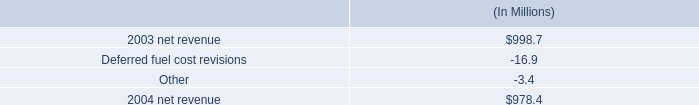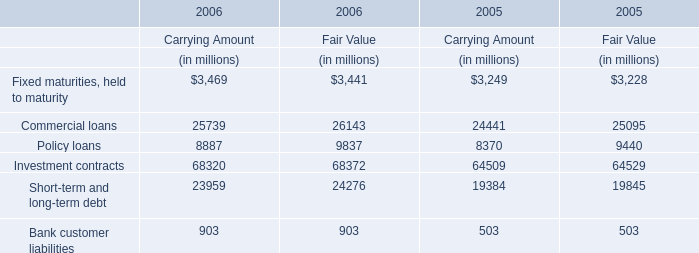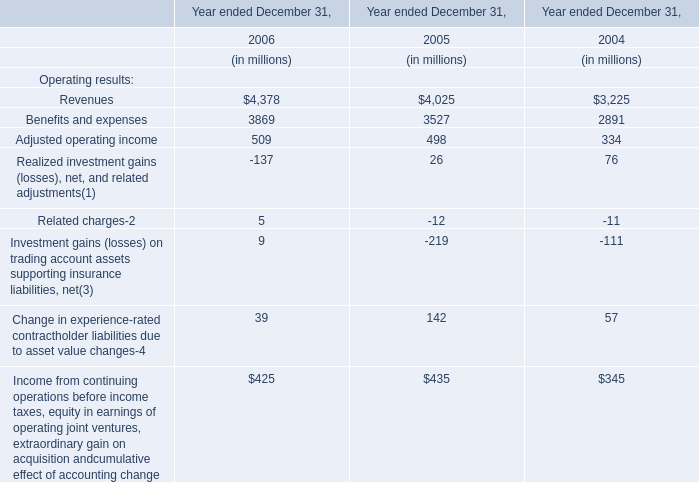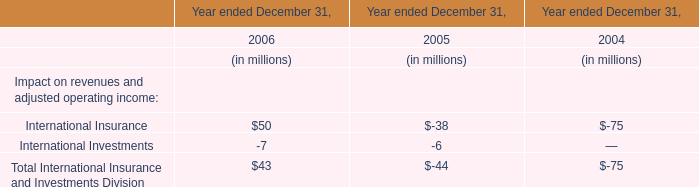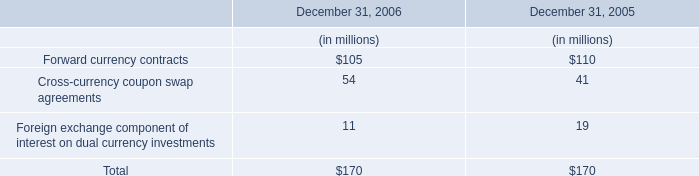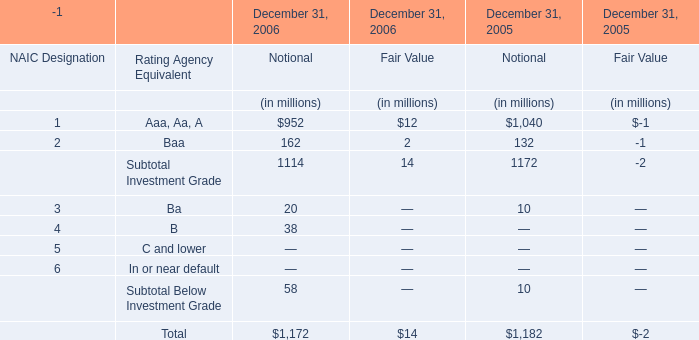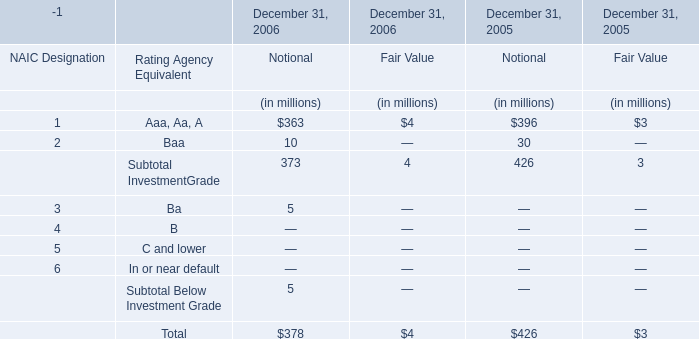What is the sum of the Baa in the years where Ba greater than 0? (in million) 
Computations: (((162 + 2) + 132) - 1)
Answer: 295.0. 